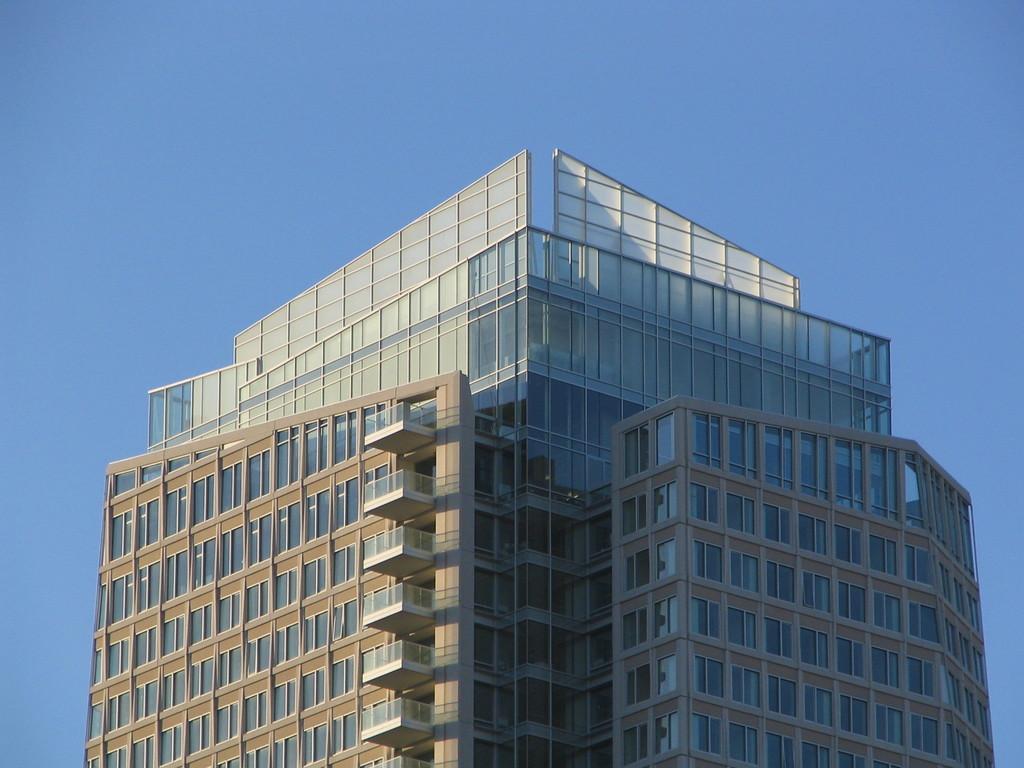In one or two sentences, can you explain what this image depicts? In the picture we can see a huge tower building with windows and glasses to it and behind the building we can see sky. 